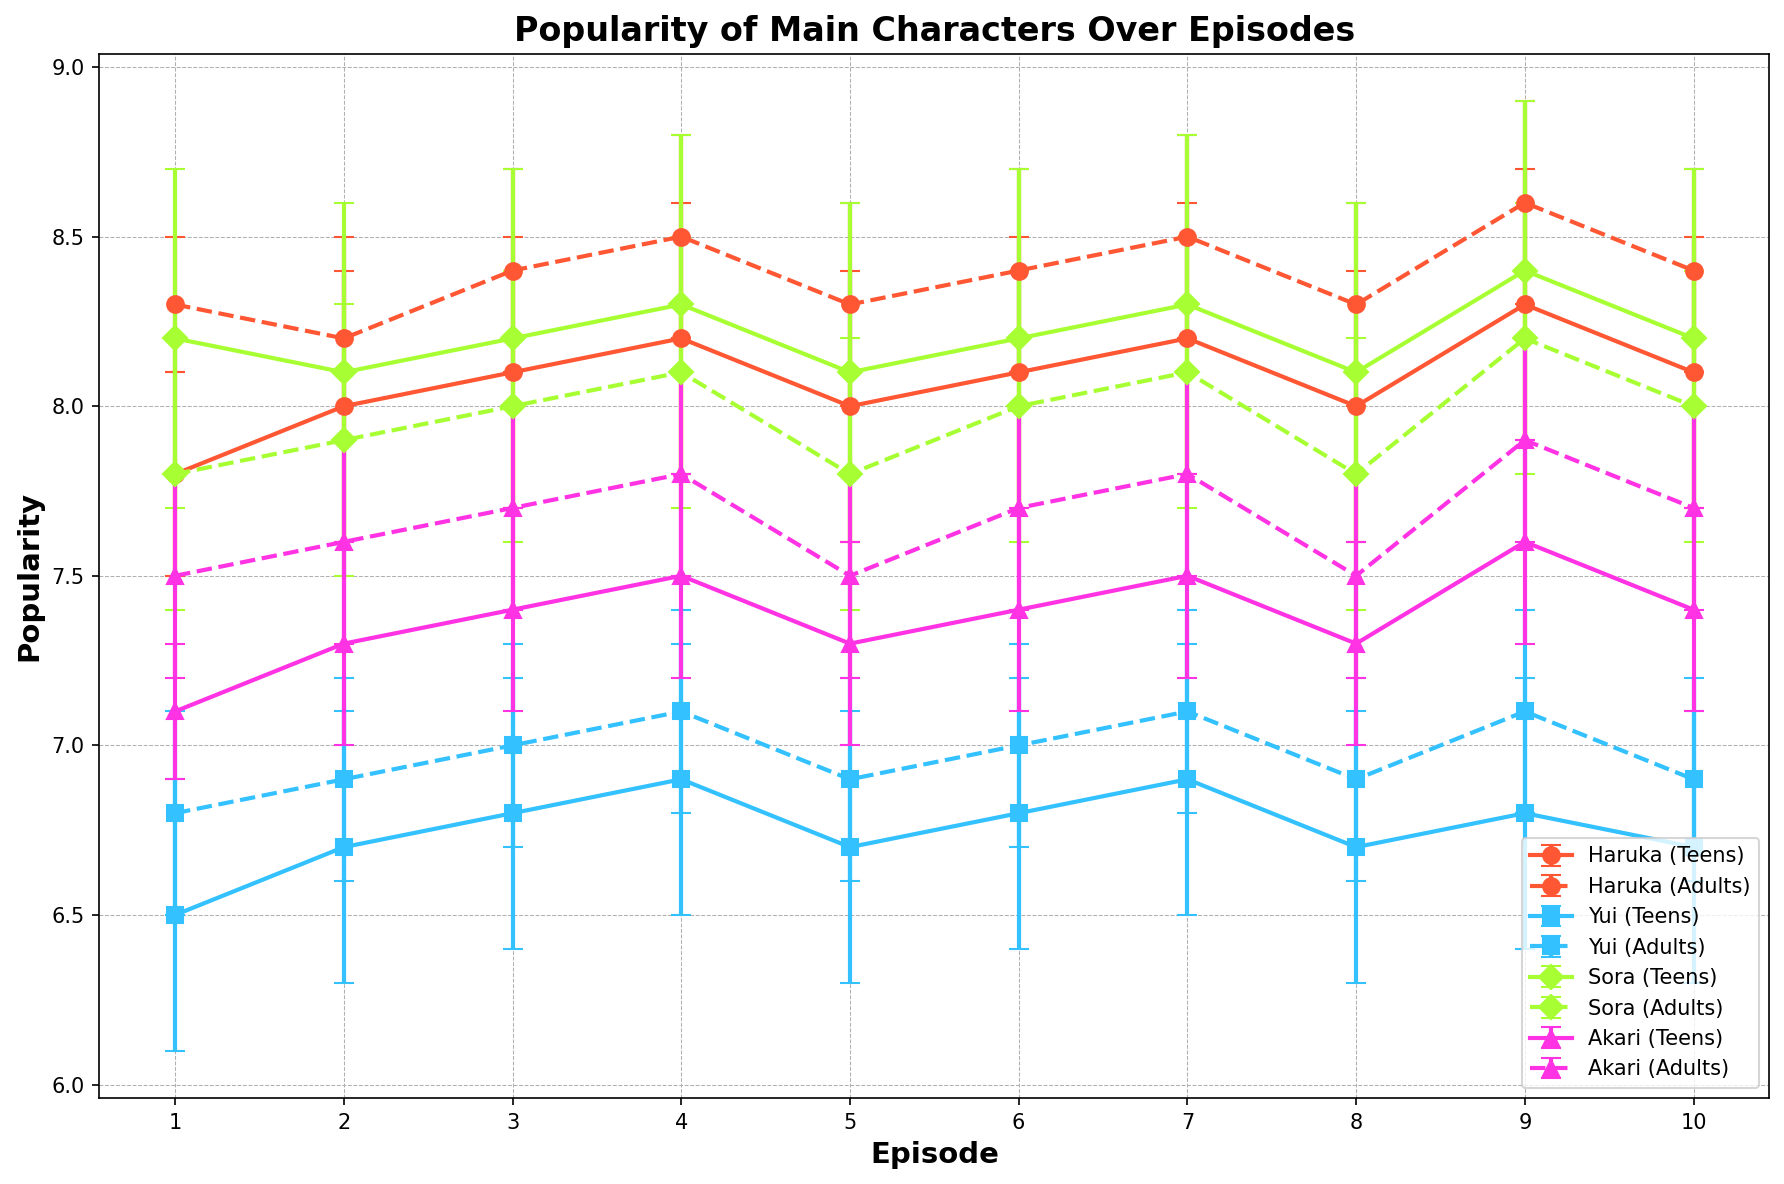Which demographic and character maintained the highest average popularity over time? We need to check the average popularity of each character within both demographics and find the highest. Haruka (Adults) consistently scores above 8, more than the others.
Answer: Haruka (Adults) Which character showed the most variation in popularity among teens across episodes? Sora's error bars are the largest among all characters in the Teens demographic, indicating the most variation.
Answer: Sora By the final episode, which adult character had the highest popularity? For the Adults in the last episode, Haruka's popularity is the highest at 8.4.
Answer: Haruka Across all episodes, which character's popularity trend appears the most consistent (least fluctuating) when considering their average popularity and standard deviation? By visual inspection of error bars and trend, Haruka (Adults) shows the least fluctuation and steady trends.
Answer: Haruka (Adults) Which episode showed the highest popularity for Haruka among teens? We need to compare the popularity values for Haruka (Teens) across all episodes. Episode 9 has the highest value at 8.3.
Answer: Episode 9 Which episodes did Yui's popularity (in the adults' demographic) surpass 7.0? We need to check episodes where Yui (Adults) had a popularity greater than 7.0. This occurs in Episodes 4, 7, and 9.
Answer: Episodes 4, 7, 9 For Sora among the adult demographic, which episode had the highest average popularity with the least standard deviation? We need to find the max average and check the corresponding standard deviation for Sora (Adults). Episode 9 has the highest average of 8.2 with stddev of 0.4.
Answer: Episode 9 How does Akari's popularity trend compare among teens and adults over the episodes? Inspecting the trends, for both demographics, the trend is parallel and almost identical, increasing and decreasing concurrently.
Answer: Parallel and identical trend Between episodes 5 and 6, which character showed the least change in popularity among adults? By comparing differences in values, Sora (Adults) changes by only 0.2 from 7.8 to 8.0, which is the smallest change.
Answer: Sora 